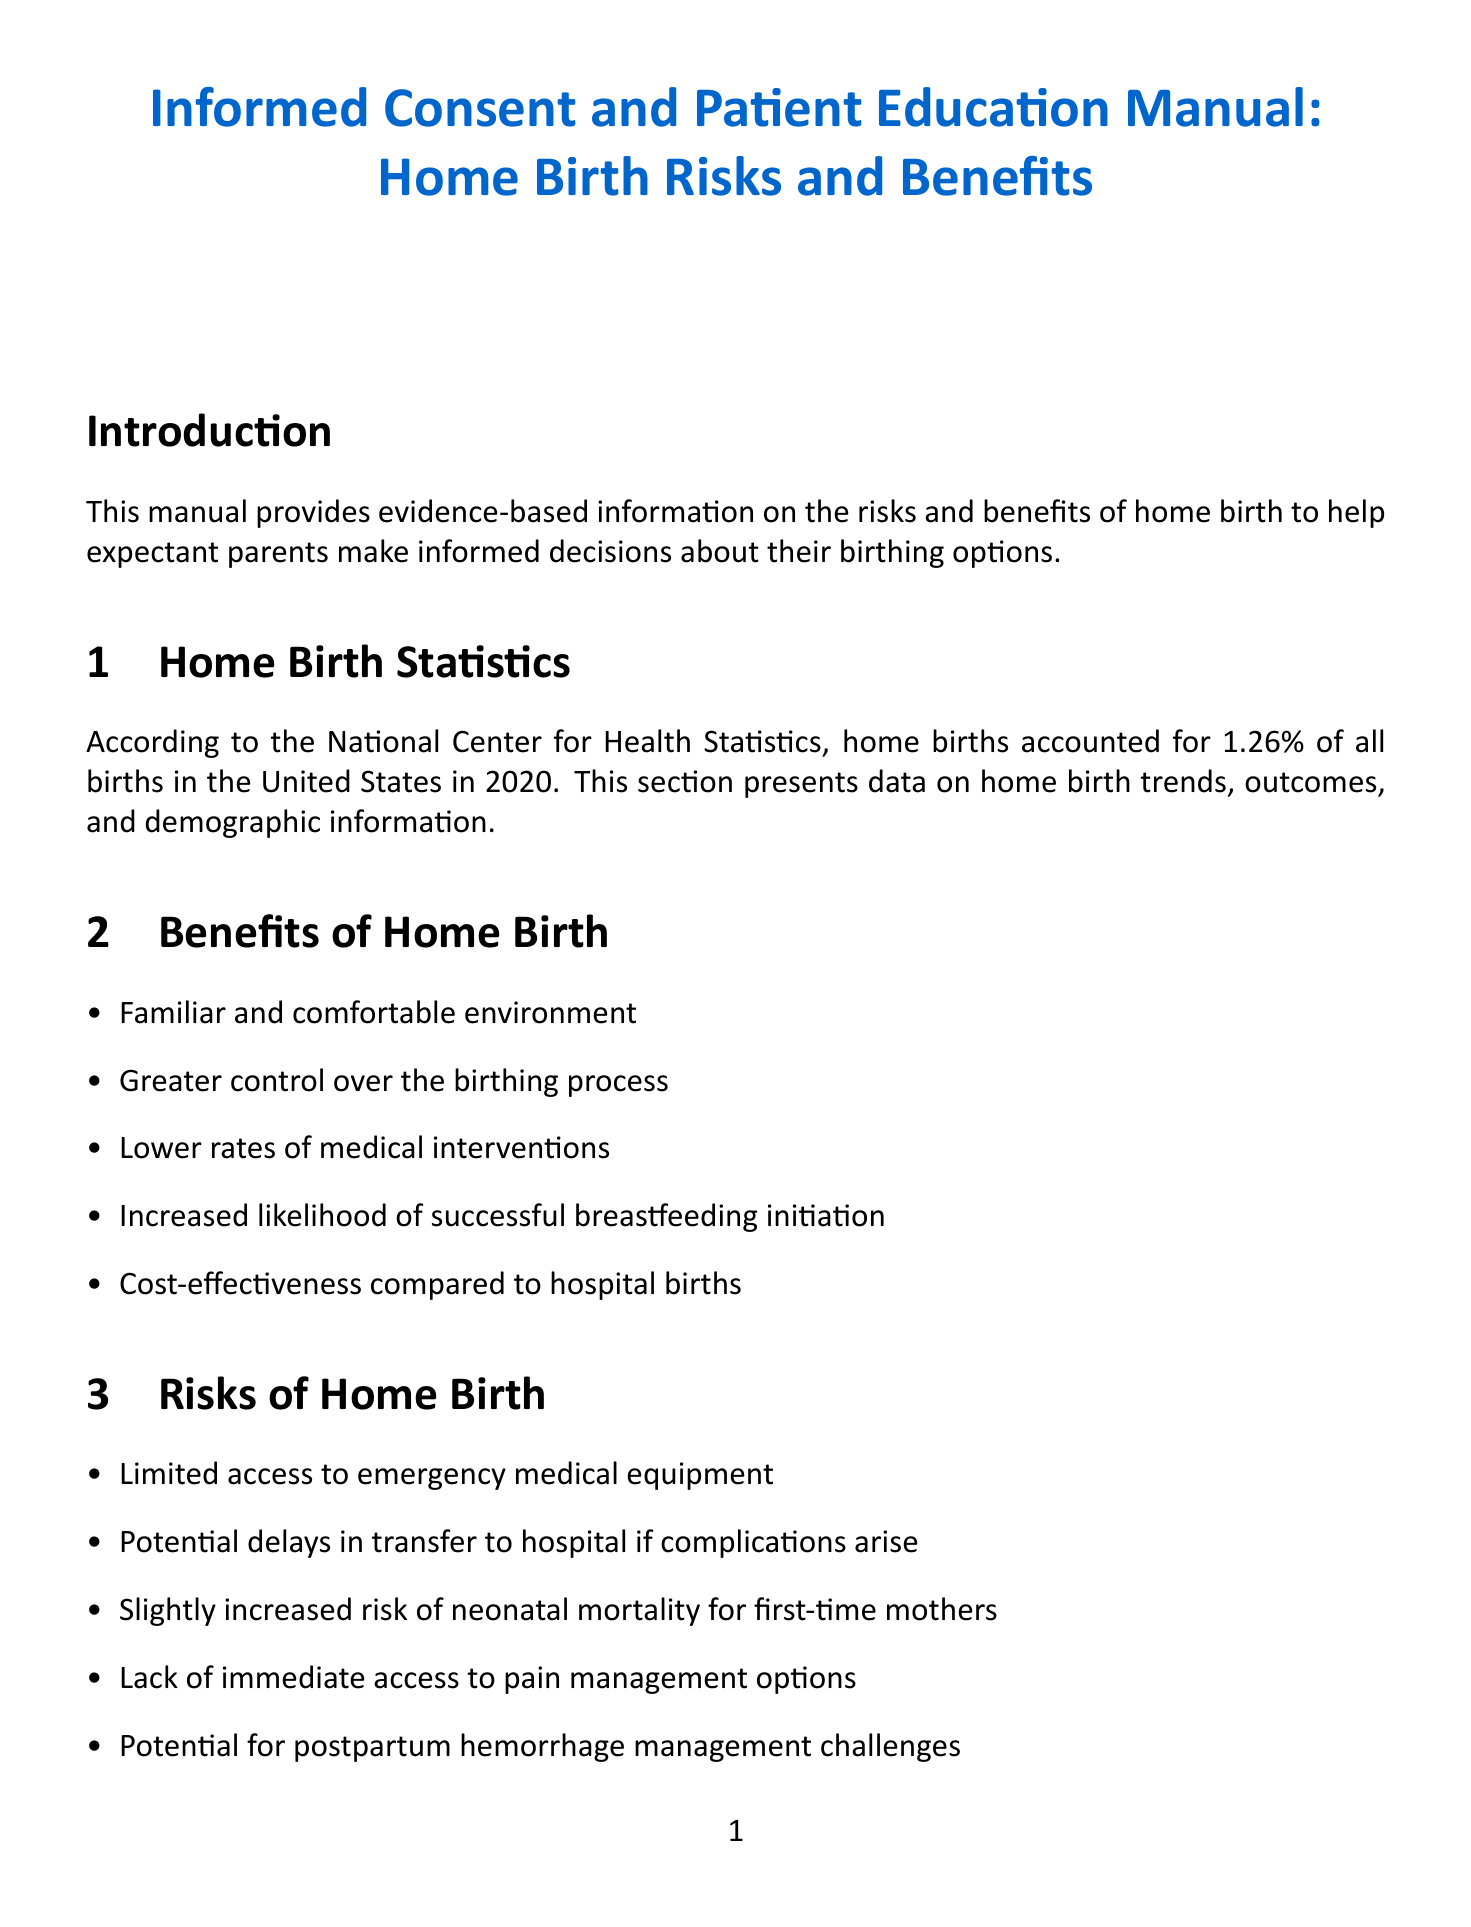What percentage of births were home births in 2020? The manual states that home births accounted for 1.26% of all births in 2020 according to the National Center for Health Statistics.
Answer: 1.26% What is one benefit of home birth? The manual lists several benefits, including a familiar and comfortable environment.
Answer: Familiar and comfortable environment What is a risk associated with home birth? The manual mentions several risks, one of which is limited access to emergency medical equipment.
Answer: Limited access to emergency medical equipment What document outlines eligibility criteria for home birth? The section details that the American College of Obstetricians and Gynecologists (ACOG) guidelines outline the eligibility criteria for home birth.
Answer: ACOG guidelines What type of information is included in the emergency transfer protocols section? This section provides detailed information on emergency transfer procedures, including average transfer rates and common reasons for transfer.
Answer: Emergency transfer procedures How many decision-making tools are listed in the document? The manual lists four decision-making tools, including the Birth Preferences Worksheet and the Risk Assessment Questionnaire.
Answer: Four What is one method of pain management during home birth? The manual discusses non-pharmacological pain management techniques such as water immersion.
Answer: Water immersion What does the informed consent form detail? The informed consent form is described as detailing the risks and benefits of home birth, which must be reviewed and signed.
Answer: Risks and benefits of home birth 